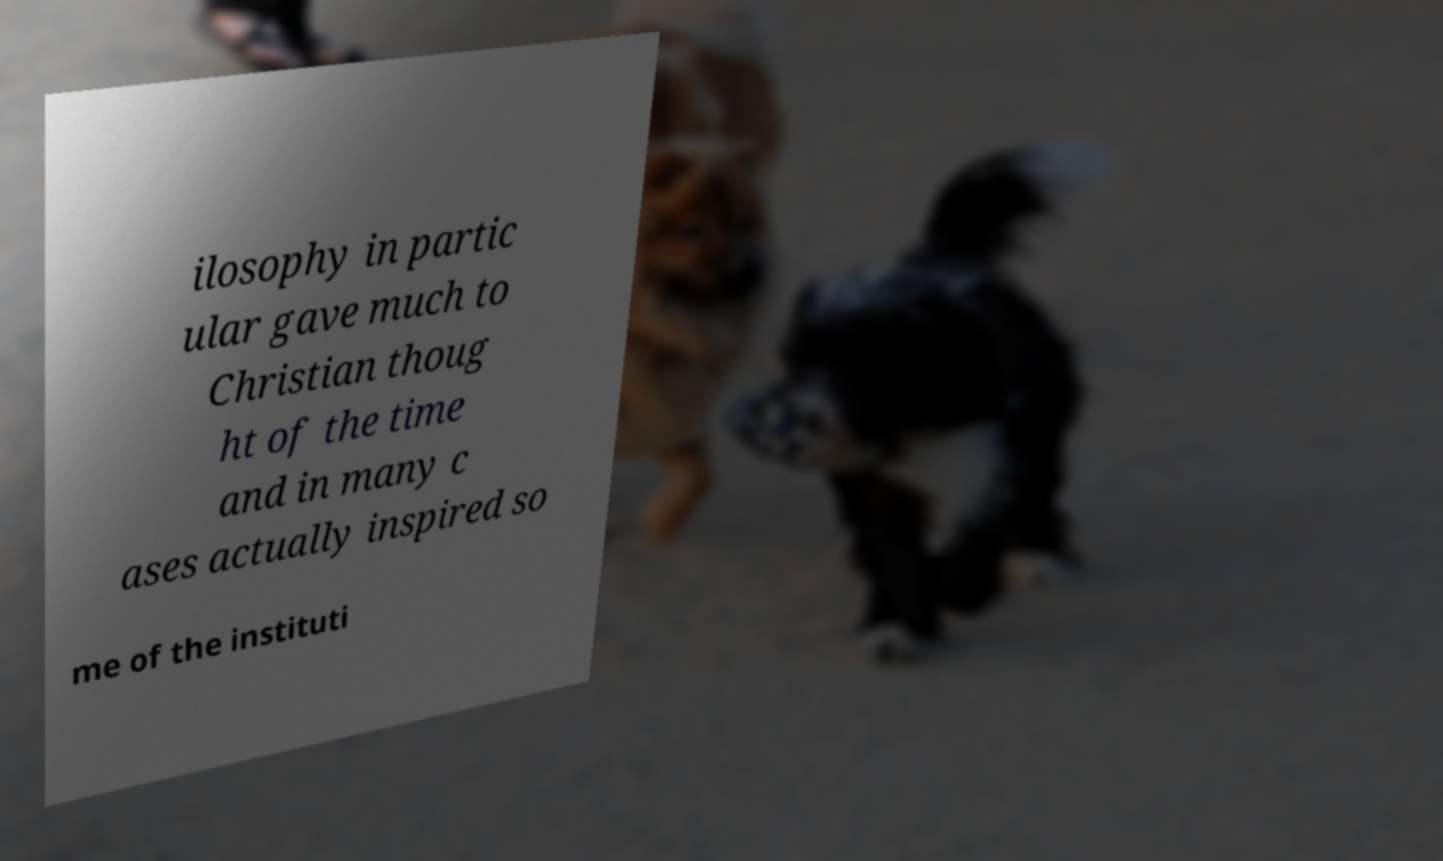What messages or text are displayed in this image? I need them in a readable, typed format. ilosophy in partic ular gave much to Christian thoug ht of the time and in many c ases actually inspired so me of the instituti 